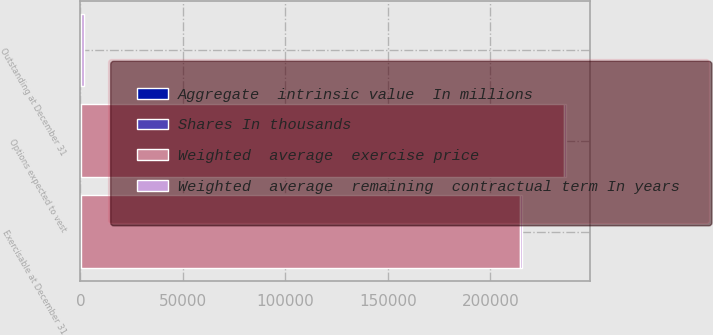<chart> <loc_0><loc_0><loc_500><loc_500><stacked_bar_chart><ecel><fcel>Outstanding at December 31<fcel>Exercisable at December 31<fcel>Options expected to vest<nl><fcel>Weighted  average  exercise price<fcel>20.85<fcel>214377<fcel>235849<nl><fcel>Aggregate  intrinsic value  In millions<fcel>19.27<fcel>20.85<fcel>17.82<nl><fcel>Shares In thousands<fcel>6.9<fcel>5.3<fcel>8.2<nl><fcel>Weighted  average  remaining  contractual term In years<fcel>1810<fcel>964<fcel>814<nl></chart> 